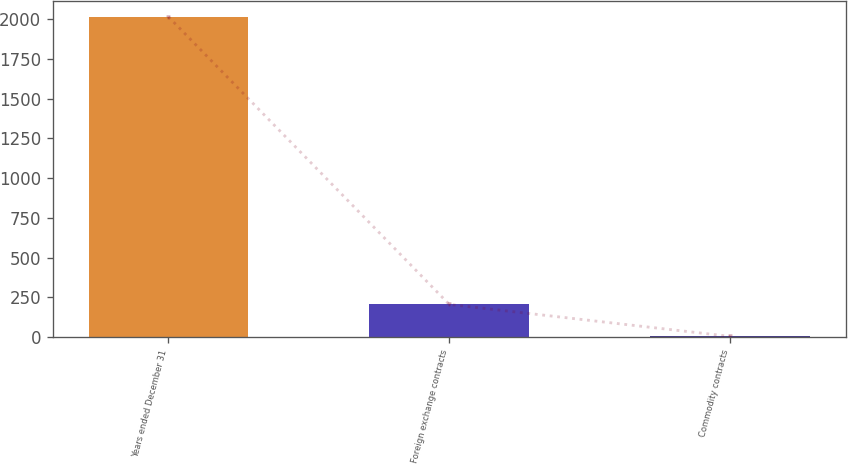Convert chart. <chart><loc_0><loc_0><loc_500><loc_500><bar_chart><fcel>Years ended December 31<fcel>Foreign exchange contracts<fcel>Commodity contracts<nl><fcel>2015<fcel>205.1<fcel>4<nl></chart> 